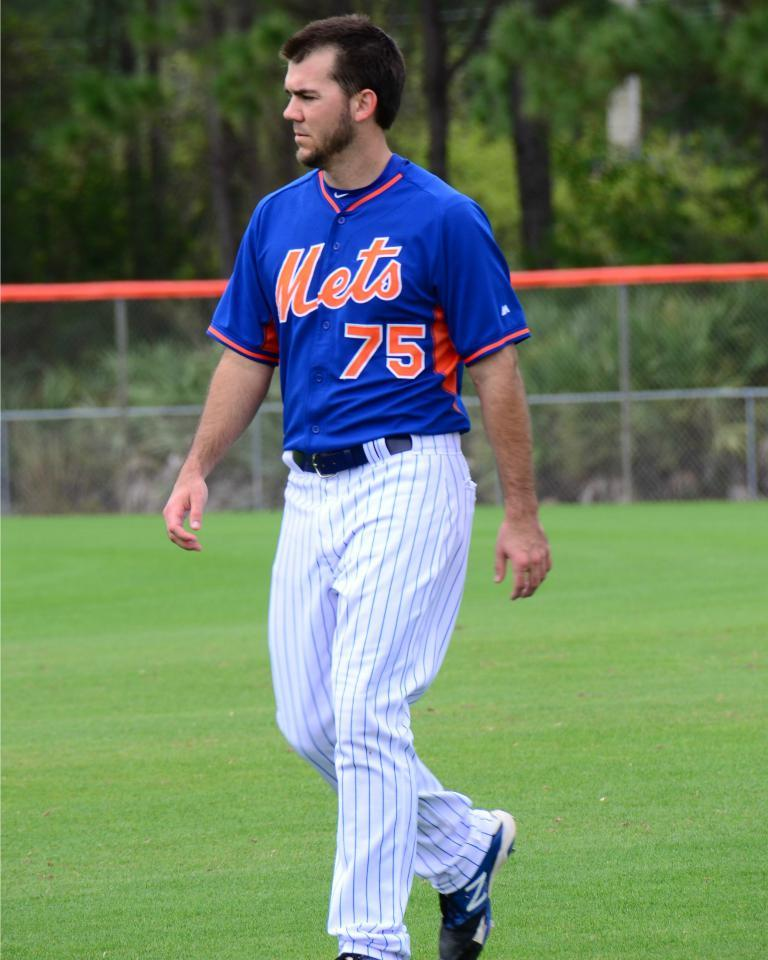<image>
Write a terse but informative summary of the picture. A person wearing a baseball jersey with Mets and 75 displayed. 